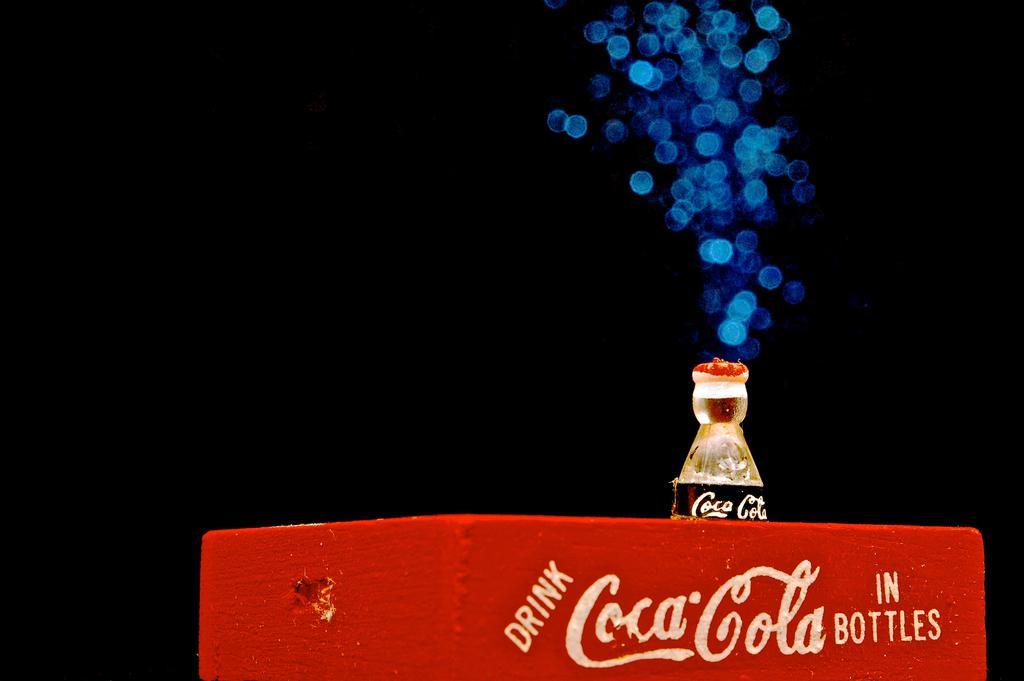Describe this image in one or two sentences. In this picture there is one red box and one cool drink bottle in it. 